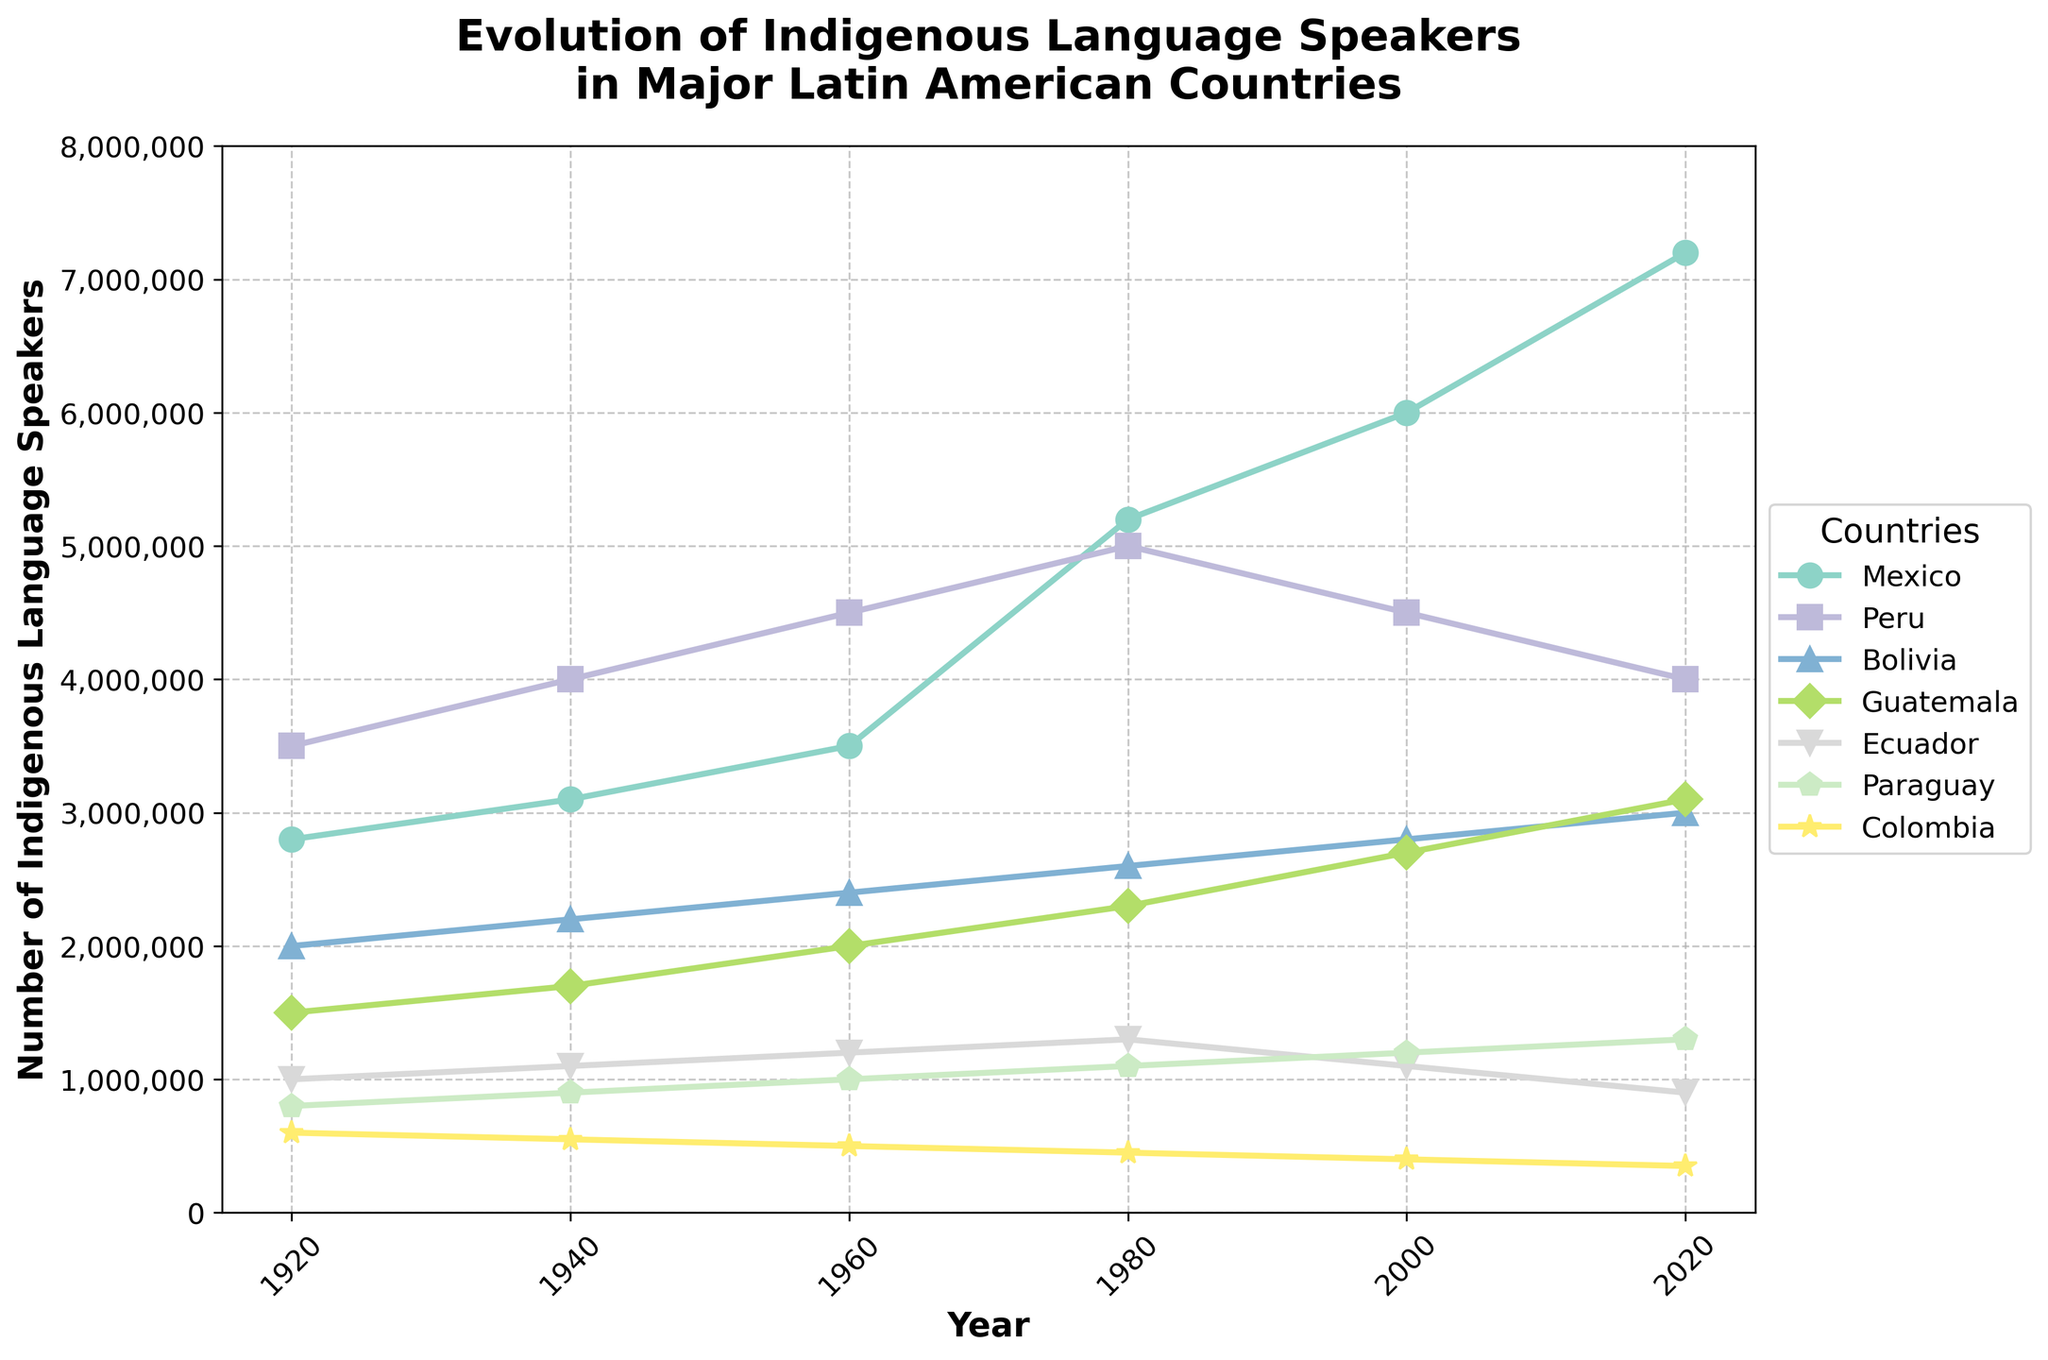What is the general trend in the number of indigenous language speakers in Mexico from 1920 to 2020? The line for Mexico shows a clear upward trend, starting from 2,800,000 in 1920 and increasing to 7,200,000 by 2020, with notable jumps especially after 1960.
Answer: Increasing Which country had the highest number of indigenous language speakers in 1940, and how many speakers were there? From the figure, the line representing Peru is the highest in 1940, with about 4,000,000 speakers.
Answer: Peru, 4,000,000 How did the number of indigenous language speakers in Ecuador change from 1960 to 2020? The line representing Ecuador shows an increase from 1,200,000 in 1960 to a peak around 1980, then a decrease to 900,000 by 2020.
Answer: Decreased Between 2000 and 2020, which country's indigenous language speakers showed the greatest absolute increase and by how much? By calculating the differences: Mexico (1,200,000), Peru (-500,000), Bolivia (200,000), Guatemala (400,000), Ecuador (-200,000), Paraguay (100,000), Colombia (-50,000), Mexico had the greatest increase with 1,200,000 additional speakers.
Answer: Mexico, 1,200,000 What is the difference in the number of indigenous language speakers between Bolivia and Colombia in 2020? Bolivia has 3,000,000 speakers, while Colombia has 350,000 in 2020; the difference is 3,000,000 - 350,000 = 2,650,000.
Answer: 2,650,000 Compare the visual attributes of the trends for Peru and Ecuador. Which main visual differences do you notice? Peru's line starts high and shows a gradual decline after 1980, indicated by the slope flattening and falling. Ecuador's line has a peak around 1980 but then declines sharply after, marked by a steep descending slope.
Answer: Peru declines gradually, Ecuador declines sharply What is the sum of indigenous language speakers in Guatemala and Paraguay in 2020? Guatemala has 3,100,000 and Paraguay has 1,300,000 in 2020. Adding them gives 3,100,000 + 1,300,000 = 4,400,000.
Answer: 4,400,000 Which country saw the smallest change in the number of indigenous language speakers from 1920 to 2020, and what is the amount of change? Comparing the differences: Mexico (4,400,000), Peru (500,000), Bolivia (1,000,000), Guatemala (1,600,000), Ecuador (-100,000), Paraguay (500,000), Colombia (-250,000), Paraguay and Peru both had a change of 500,000.
Answer: Paraguay, 500,000 